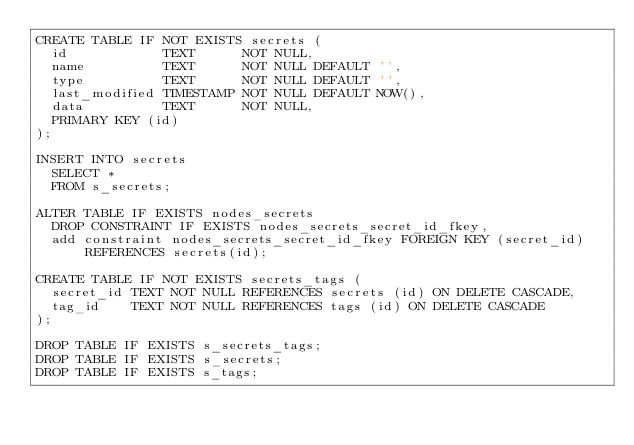<code> <loc_0><loc_0><loc_500><loc_500><_SQL_>CREATE TABLE IF NOT EXISTS secrets (
  id            TEXT      NOT NULL,
  name          TEXT      NOT NULL DEFAULT '',
  type          TEXT      NOT NULL DEFAULT '',
  last_modified TIMESTAMP NOT NULL DEFAULT NOW(),
  data          TEXT      NOT NULL,
  PRIMARY KEY (id)
);

INSERT INTO secrets
  SELECT *
  FROM s_secrets;

ALTER TABLE IF EXISTS nodes_secrets
  DROP CONSTRAINT IF EXISTS nodes_secrets_secret_id_fkey,
  add constraint nodes_secrets_secret_id_fkey FOREIGN KEY (secret_id) REFERENCES secrets(id);

CREATE TABLE IF NOT EXISTS secrets_tags (
  secret_id TEXT NOT NULL REFERENCES secrets (id) ON DELETE CASCADE,
  tag_id    TEXT NOT NULL REFERENCES tags (id) ON DELETE CASCADE
);

DROP TABLE IF EXISTS s_secrets_tags;
DROP TABLE IF EXISTS s_secrets;
DROP TABLE IF EXISTS s_tags;
</code> 